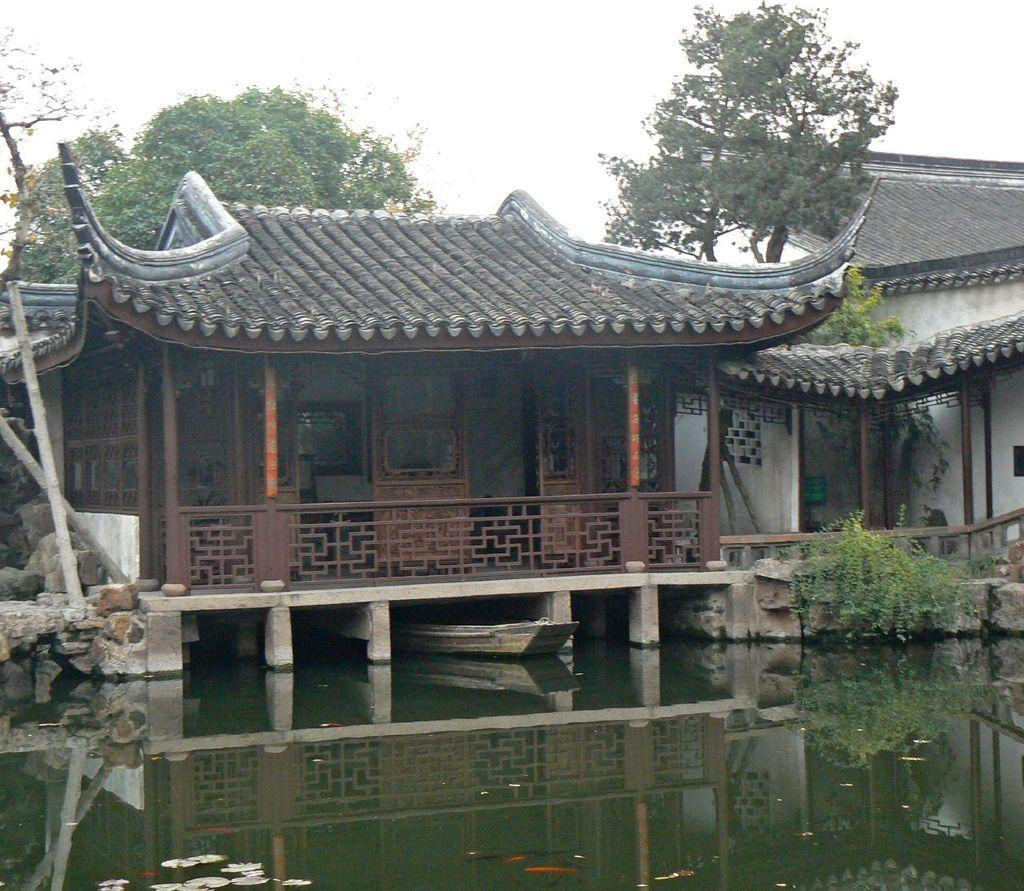What type of structures can be seen in the image? There are houses in the image. What other natural elements are present in the image? There are trees and rocks in the image. What mode of transportation is visible in the image? There is a boat in the image. Where is the boat located in the image? The boat is on the water in the image. What type of government is depicted in the image? There is no depiction of a government in the image; it features houses, trees, rocks, and a boat on the water. What kind of feast is being held in the image? There is no feast present in the image; it shows a boat on the water, houses, trees, and rocks. 